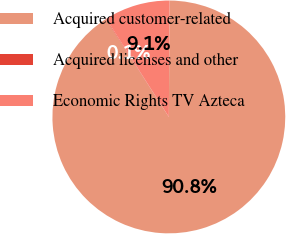<chart> <loc_0><loc_0><loc_500><loc_500><pie_chart><fcel>Acquired customer-related<fcel>Acquired licenses and other<fcel>Economic Rights TV Azteca<nl><fcel>90.77%<fcel>0.08%<fcel>9.15%<nl></chart> 